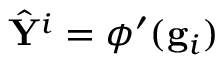<formula> <loc_0><loc_0><loc_500><loc_500>\hat { Y } ^ { i } = \phi ^ { \prime } ( g _ { i } )</formula> 